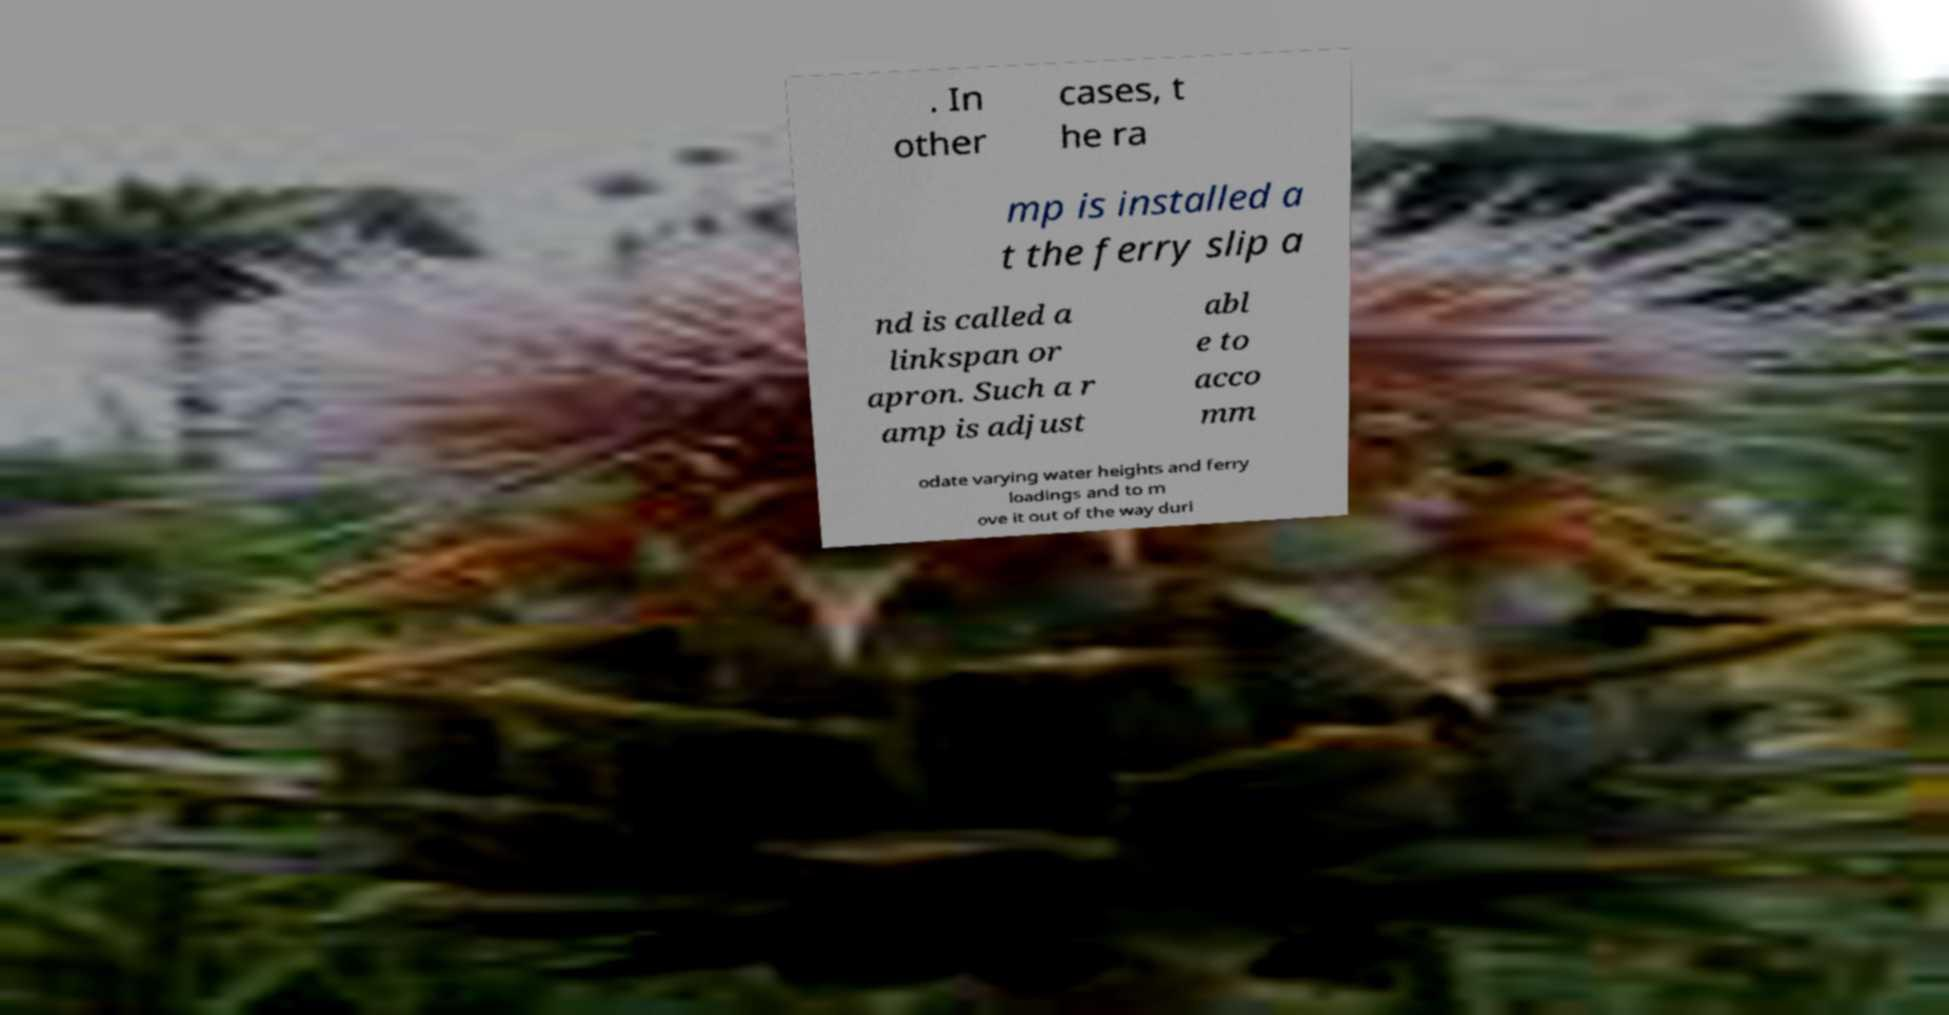I need the written content from this picture converted into text. Can you do that? . In other cases, t he ra mp is installed a t the ferry slip a nd is called a linkspan or apron. Such a r amp is adjust abl e to acco mm odate varying water heights and ferry loadings and to m ove it out of the way duri 